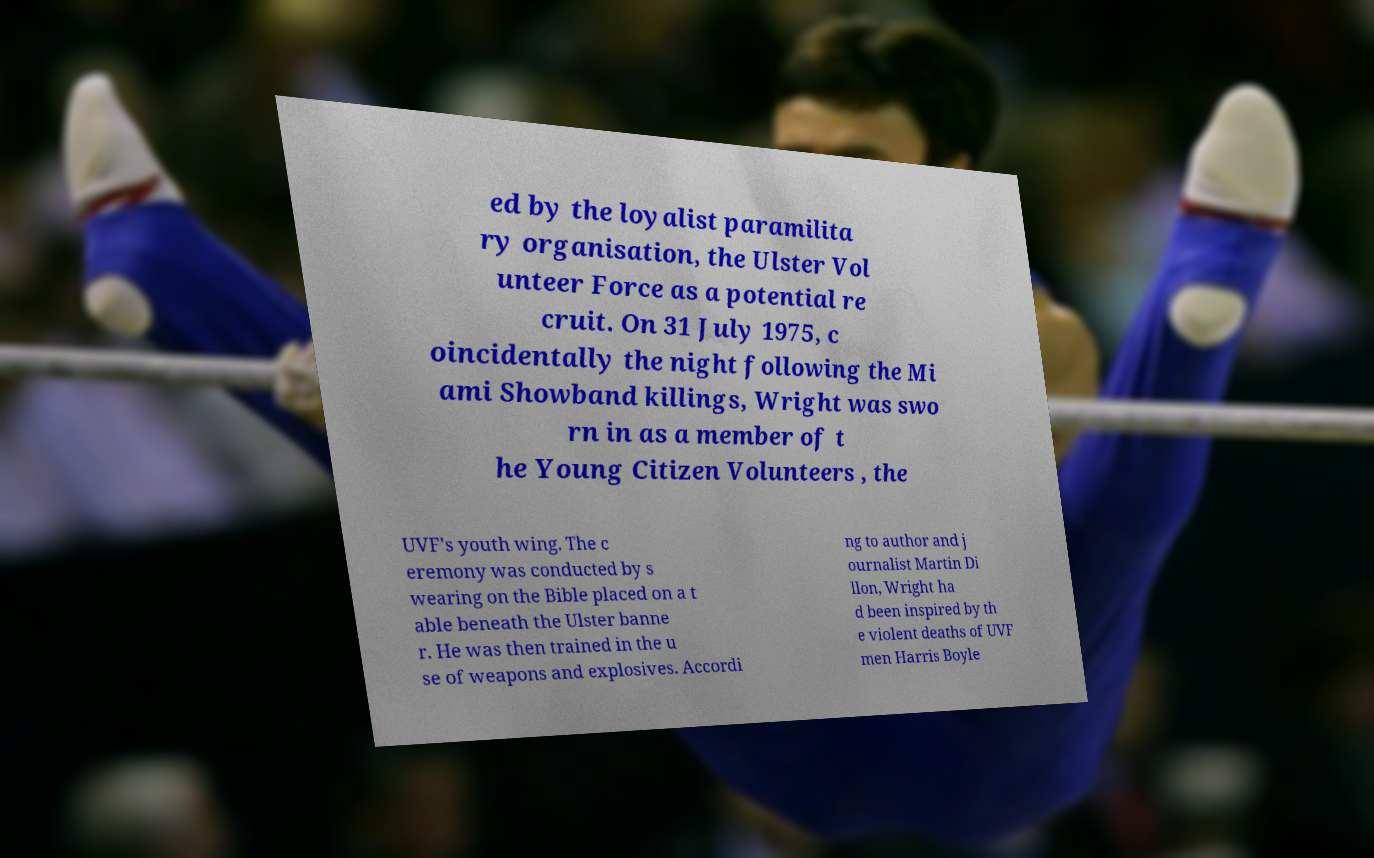Can you read and provide the text displayed in the image?This photo seems to have some interesting text. Can you extract and type it out for me? ed by the loyalist paramilita ry organisation, the Ulster Vol unteer Force as a potential re cruit. On 31 July 1975, c oincidentally the night following the Mi ami Showband killings, Wright was swo rn in as a member of t he Young Citizen Volunteers , the UVF's youth wing. The c eremony was conducted by s wearing on the Bible placed on a t able beneath the Ulster banne r. He was then trained in the u se of weapons and explosives. Accordi ng to author and j ournalist Martin Di llon, Wright ha d been inspired by th e violent deaths of UVF men Harris Boyle 